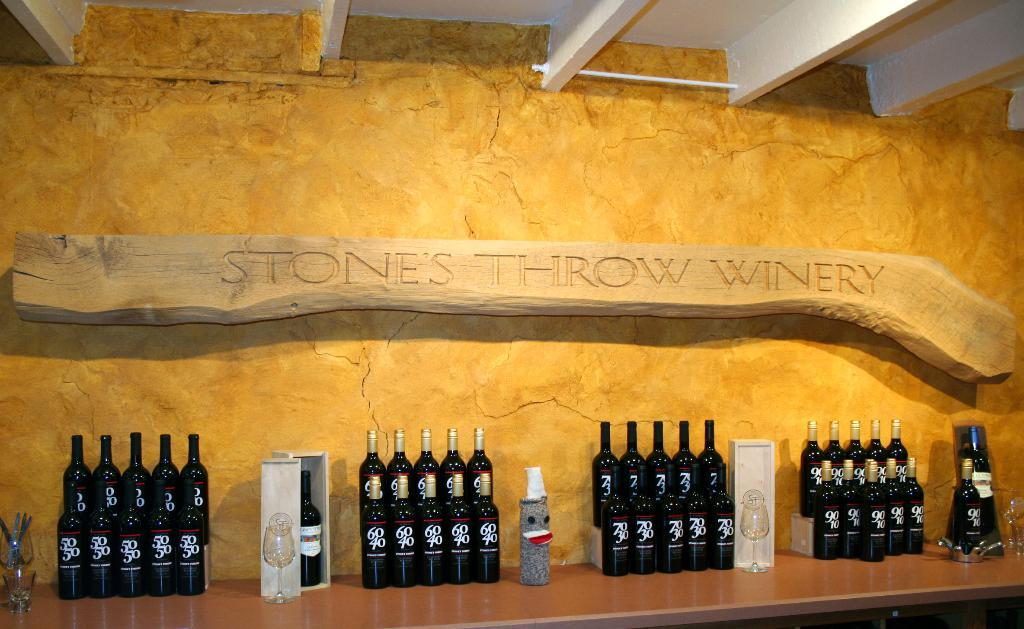<image>
Create a compact narrative representing the image presented. Wine bottles are on display against a wall in Stone's Throw Winery. 